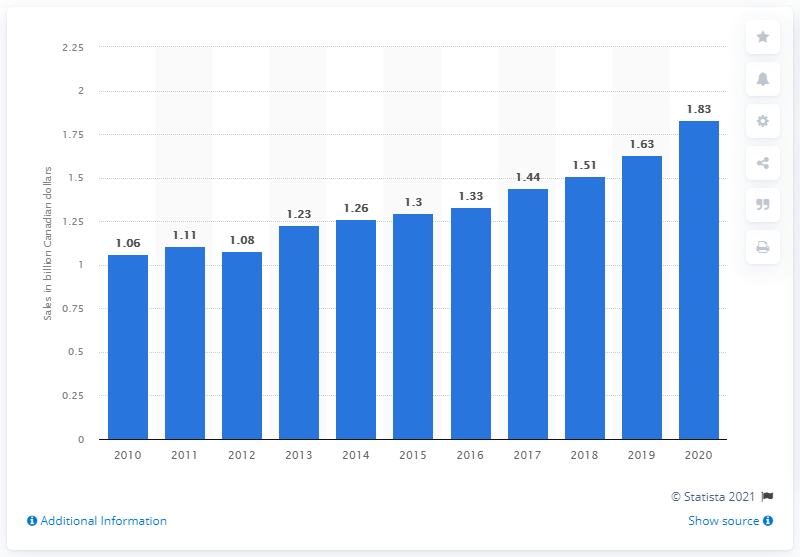Point out several critical features in this image. According to data from 2020, the sales of fruits and vegetables in Canada amounted to approximately 1.83 dollars. 